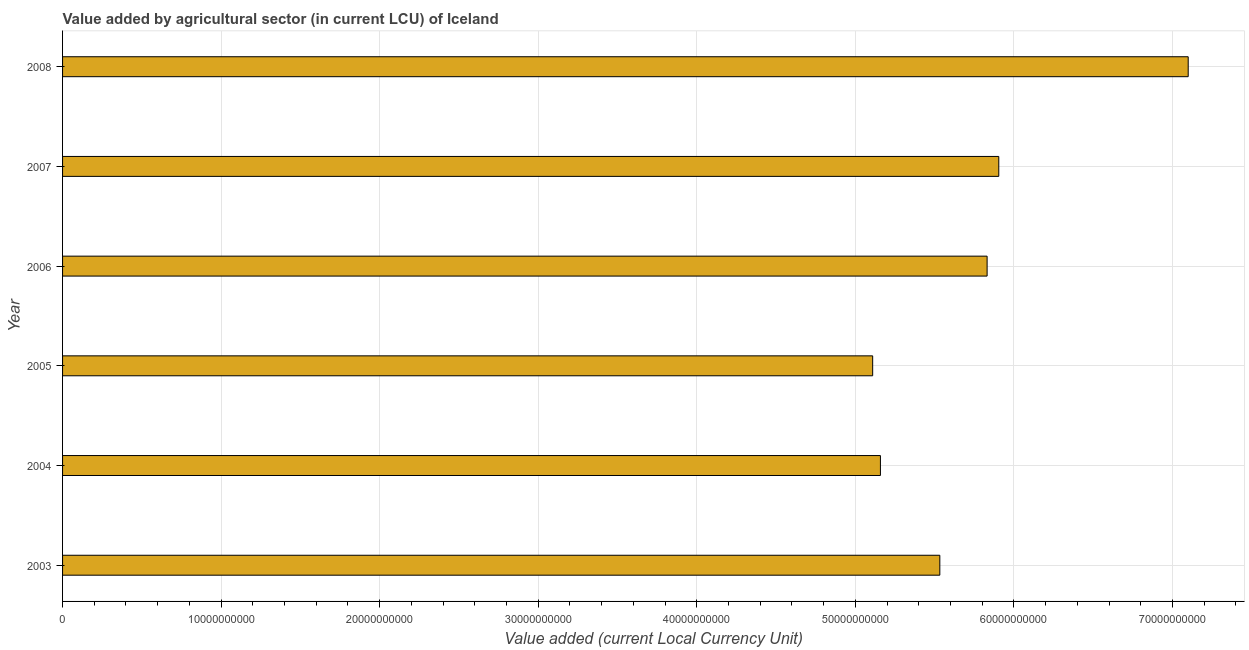What is the title of the graph?
Your answer should be very brief. Value added by agricultural sector (in current LCU) of Iceland. What is the label or title of the X-axis?
Keep it short and to the point. Value added (current Local Currency Unit). What is the value added by agriculture sector in 2003?
Give a very brief answer. 5.53e+1. Across all years, what is the maximum value added by agriculture sector?
Offer a terse response. 7.10e+1. Across all years, what is the minimum value added by agriculture sector?
Keep it short and to the point. 5.11e+1. In which year was the value added by agriculture sector maximum?
Offer a terse response. 2008. What is the sum of the value added by agriculture sector?
Keep it short and to the point. 3.46e+11. What is the difference between the value added by agriculture sector in 2004 and 2008?
Provide a succinct answer. -1.94e+1. What is the average value added by agriculture sector per year?
Offer a terse response. 5.77e+1. What is the median value added by agriculture sector?
Your answer should be compact. 5.68e+1. What is the ratio of the value added by agriculture sector in 2005 to that in 2007?
Provide a succinct answer. 0.86. Is the value added by agriculture sector in 2004 less than that in 2006?
Your answer should be compact. Yes. What is the difference between the highest and the second highest value added by agriculture sector?
Make the answer very short. 1.19e+1. Is the sum of the value added by agriculture sector in 2003 and 2008 greater than the maximum value added by agriculture sector across all years?
Give a very brief answer. Yes. What is the difference between the highest and the lowest value added by agriculture sector?
Provide a short and direct response. 1.99e+1. In how many years, is the value added by agriculture sector greater than the average value added by agriculture sector taken over all years?
Make the answer very short. 3. How many years are there in the graph?
Offer a very short reply. 6. What is the difference between two consecutive major ticks on the X-axis?
Offer a very short reply. 1.00e+1. Are the values on the major ticks of X-axis written in scientific E-notation?
Ensure brevity in your answer.  No. What is the Value added (current Local Currency Unit) in 2003?
Provide a short and direct response. 5.53e+1. What is the Value added (current Local Currency Unit) in 2004?
Your response must be concise. 5.16e+1. What is the Value added (current Local Currency Unit) in 2005?
Offer a terse response. 5.11e+1. What is the Value added (current Local Currency Unit) in 2006?
Offer a very short reply. 5.83e+1. What is the Value added (current Local Currency Unit) of 2007?
Keep it short and to the point. 5.90e+1. What is the Value added (current Local Currency Unit) of 2008?
Your answer should be very brief. 7.10e+1. What is the difference between the Value added (current Local Currency Unit) in 2003 and 2004?
Your response must be concise. 3.75e+09. What is the difference between the Value added (current Local Currency Unit) in 2003 and 2005?
Offer a terse response. 4.24e+09. What is the difference between the Value added (current Local Currency Unit) in 2003 and 2006?
Provide a succinct answer. -2.98e+09. What is the difference between the Value added (current Local Currency Unit) in 2003 and 2007?
Offer a very short reply. -3.72e+09. What is the difference between the Value added (current Local Currency Unit) in 2003 and 2008?
Provide a succinct answer. -1.57e+1. What is the difference between the Value added (current Local Currency Unit) in 2004 and 2005?
Offer a very short reply. 4.89e+08. What is the difference between the Value added (current Local Currency Unit) in 2004 and 2006?
Make the answer very short. -6.73e+09. What is the difference between the Value added (current Local Currency Unit) in 2004 and 2007?
Provide a short and direct response. -7.46e+09. What is the difference between the Value added (current Local Currency Unit) in 2004 and 2008?
Keep it short and to the point. -1.94e+1. What is the difference between the Value added (current Local Currency Unit) in 2005 and 2006?
Make the answer very short. -7.22e+09. What is the difference between the Value added (current Local Currency Unit) in 2005 and 2007?
Keep it short and to the point. -7.95e+09. What is the difference between the Value added (current Local Currency Unit) in 2005 and 2008?
Your response must be concise. -1.99e+1. What is the difference between the Value added (current Local Currency Unit) in 2006 and 2007?
Your answer should be compact. -7.37e+08. What is the difference between the Value added (current Local Currency Unit) in 2006 and 2008?
Your answer should be compact. -1.27e+1. What is the difference between the Value added (current Local Currency Unit) in 2007 and 2008?
Your answer should be compact. -1.19e+1. What is the ratio of the Value added (current Local Currency Unit) in 2003 to that in 2004?
Provide a succinct answer. 1.07. What is the ratio of the Value added (current Local Currency Unit) in 2003 to that in 2005?
Make the answer very short. 1.08. What is the ratio of the Value added (current Local Currency Unit) in 2003 to that in 2006?
Your answer should be compact. 0.95. What is the ratio of the Value added (current Local Currency Unit) in 2003 to that in 2007?
Provide a short and direct response. 0.94. What is the ratio of the Value added (current Local Currency Unit) in 2003 to that in 2008?
Your response must be concise. 0.78. What is the ratio of the Value added (current Local Currency Unit) in 2004 to that in 2005?
Offer a terse response. 1.01. What is the ratio of the Value added (current Local Currency Unit) in 2004 to that in 2006?
Your response must be concise. 0.89. What is the ratio of the Value added (current Local Currency Unit) in 2004 to that in 2007?
Your answer should be compact. 0.87. What is the ratio of the Value added (current Local Currency Unit) in 2004 to that in 2008?
Give a very brief answer. 0.73. What is the ratio of the Value added (current Local Currency Unit) in 2005 to that in 2006?
Give a very brief answer. 0.88. What is the ratio of the Value added (current Local Currency Unit) in 2005 to that in 2007?
Provide a short and direct response. 0.86. What is the ratio of the Value added (current Local Currency Unit) in 2005 to that in 2008?
Keep it short and to the point. 0.72. What is the ratio of the Value added (current Local Currency Unit) in 2006 to that in 2007?
Make the answer very short. 0.99. What is the ratio of the Value added (current Local Currency Unit) in 2006 to that in 2008?
Ensure brevity in your answer.  0.82. What is the ratio of the Value added (current Local Currency Unit) in 2007 to that in 2008?
Ensure brevity in your answer.  0.83. 